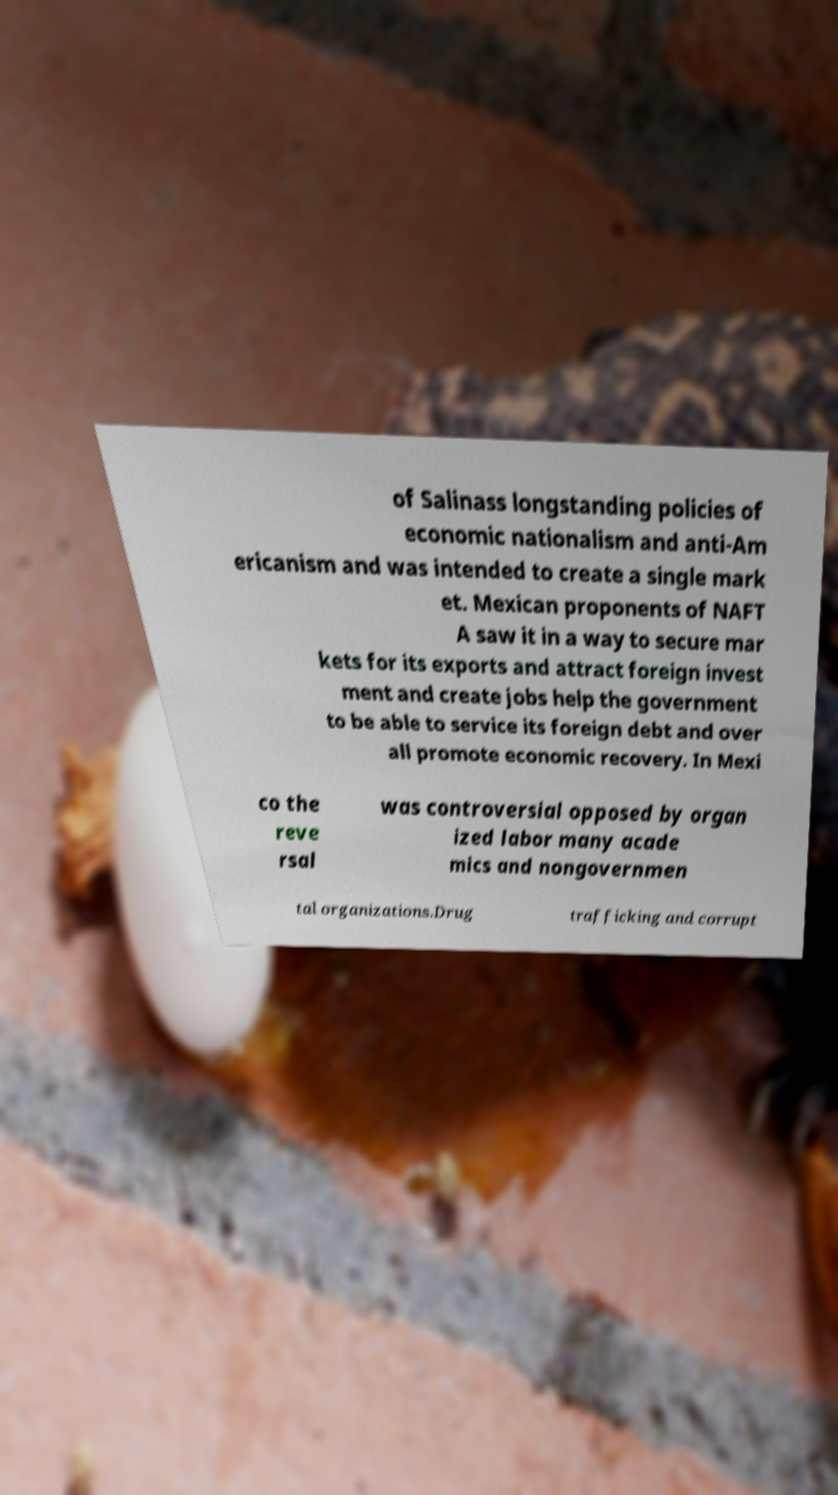Please read and relay the text visible in this image. What does it say? of Salinass longstanding policies of economic nationalism and anti-Am ericanism and was intended to create a single mark et. Mexican proponents of NAFT A saw it in a way to secure mar kets for its exports and attract foreign invest ment and create jobs help the government to be able to service its foreign debt and over all promote economic recovery. In Mexi co the reve rsal was controversial opposed by organ ized labor many acade mics and nongovernmen tal organizations.Drug trafficking and corrupt 